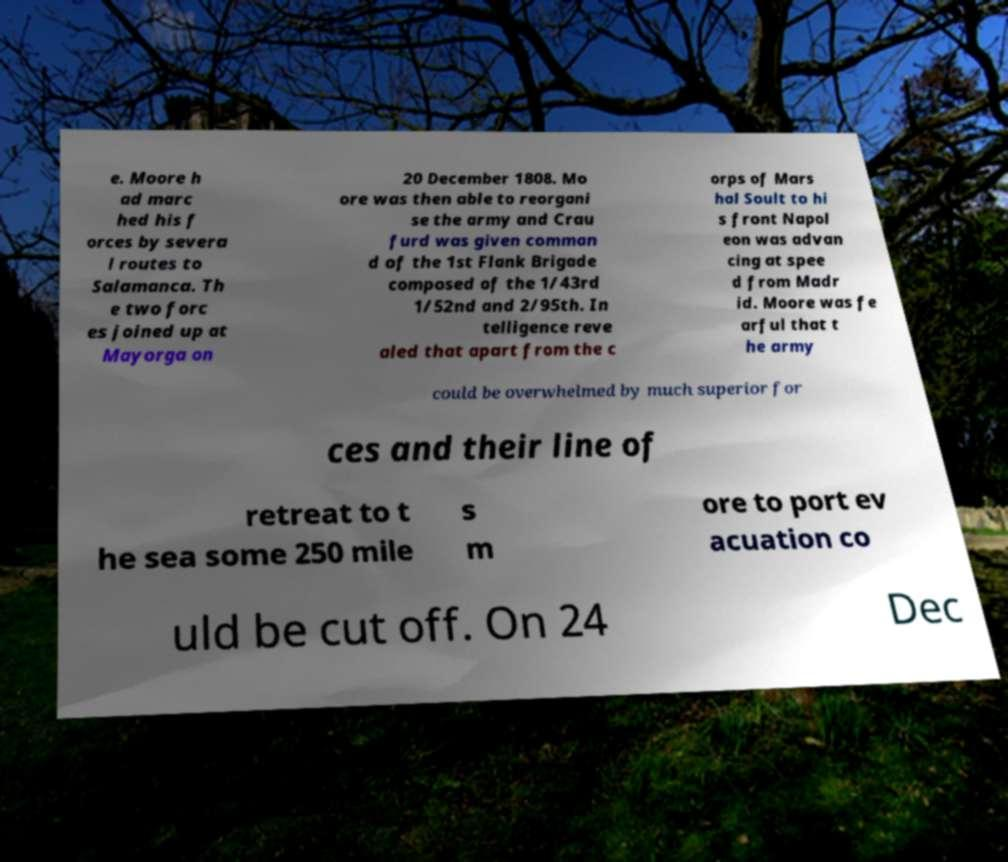Can you read and provide the text displayed in the image?This photo seems to have some interesting text. Can you extract and type it out for me? e. Moore h ad marc hed his f orces by severa l routes to Salamanca. Th e two forc es joined up at Mayorga on 20 December 1808. Mo ore was then able to reorgani se the army and Crau furd was given comman d of the 1st Flank Brigade composed of the 1/43rd 1/52nd and 2/95th. In telligence reve aled that apart from the c orps of Mars hal Soult to hi s front Napol eon was advan cing at spee d from Madr id. Moore was fe arful that t he army could be overwhelmed by much superior for ces and their line of retreat to t he sea some 250 mile s m ore to port ev acuation co uld be cut off. On 24 Dec 